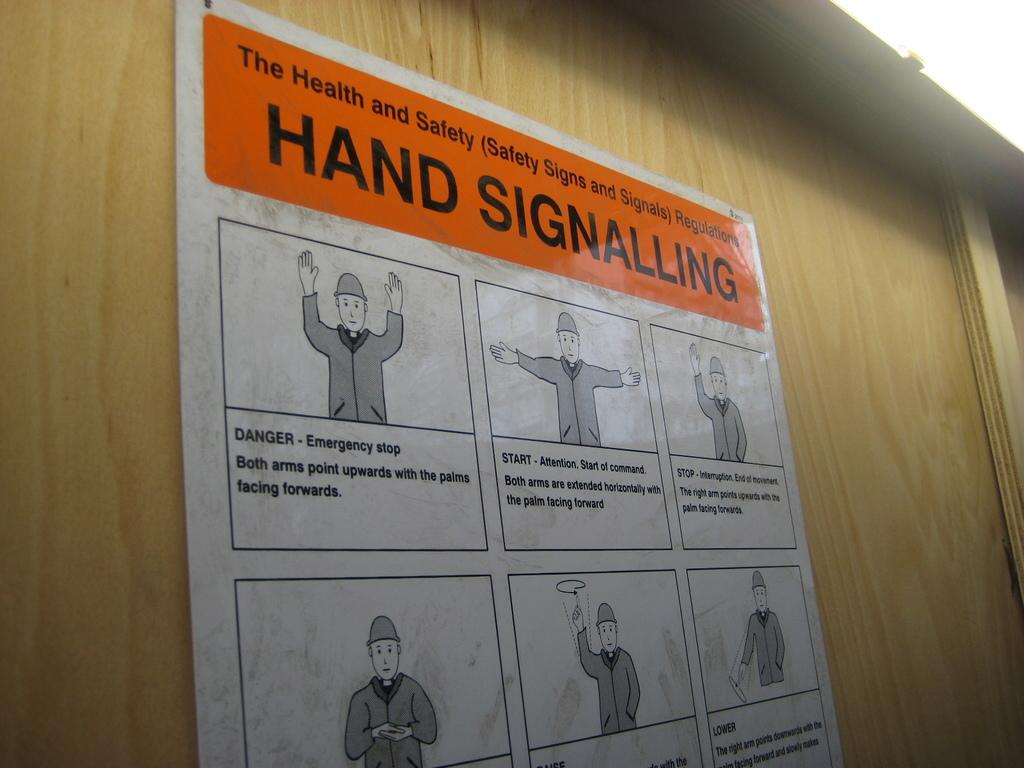<image>
Share a concise interpretation of the image provided. A sign pasted on the wall that says Hand Signalling and a figure displaying signals 